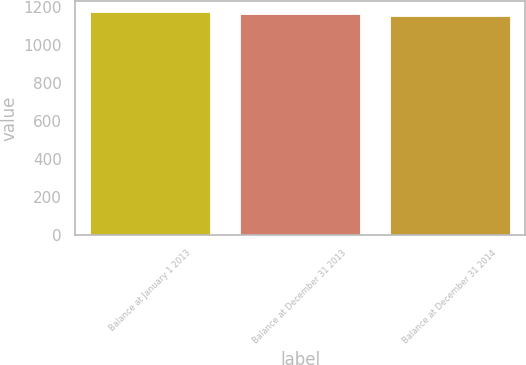Convert chart. <chart><loc_0><loc_0><loc_500><loc_500><bar_chart><fcel>Balance at January 1 2013<fcel>Balance at December 31 2013<fcel>Balance at December 31 2014<nl><fcel>1174<fcel>1164<fcel>1154<nl></chart> 